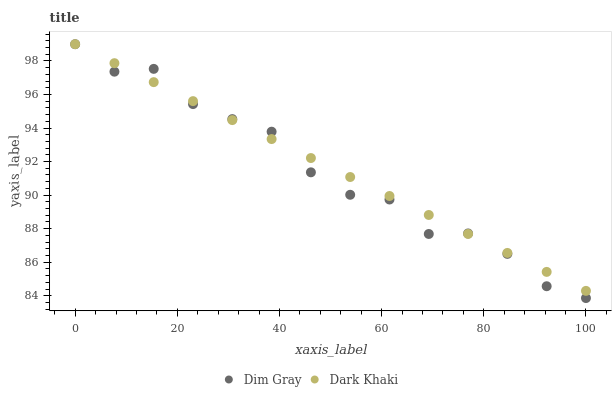Does Dim Gray have the minimum area under the curve?
Answer yes or no. Yes. Does Dark Khaki have the maximum area under the curve?
Answer yes or no. Yes. Does Dim Gray have the maximum area under the curve?
Answer yes or no. No. Is Dark Khaki the smoothest?
Answer yes or no. Yes. Is Dim Gray the roughest?
Answer yes or no. Yes. Is Dim Gray the smoothest?
Answer yes or no. No. Does Dim Gray have the lowest value?
Answer yes or no. Yes. Does Dim Gray have the highest value?
Answer yes or no. Yes. Does Dim Gray intersect Dark Khaki?
Answer yes or no. Yes. Is Dim Gray less than Dark Khaki?
Answer yes or no. No. Is Dim Gray greater than Dark Khaki?
Answer yes or no. No. 